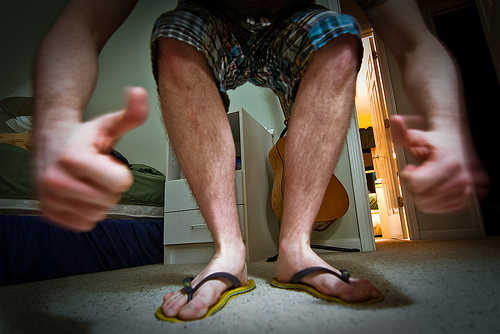<image>
Is there a guitar behind the human? Yes. From this viewpoint, the guitar is positioned behind the human, with the human partially or fully occluding the guitar. 